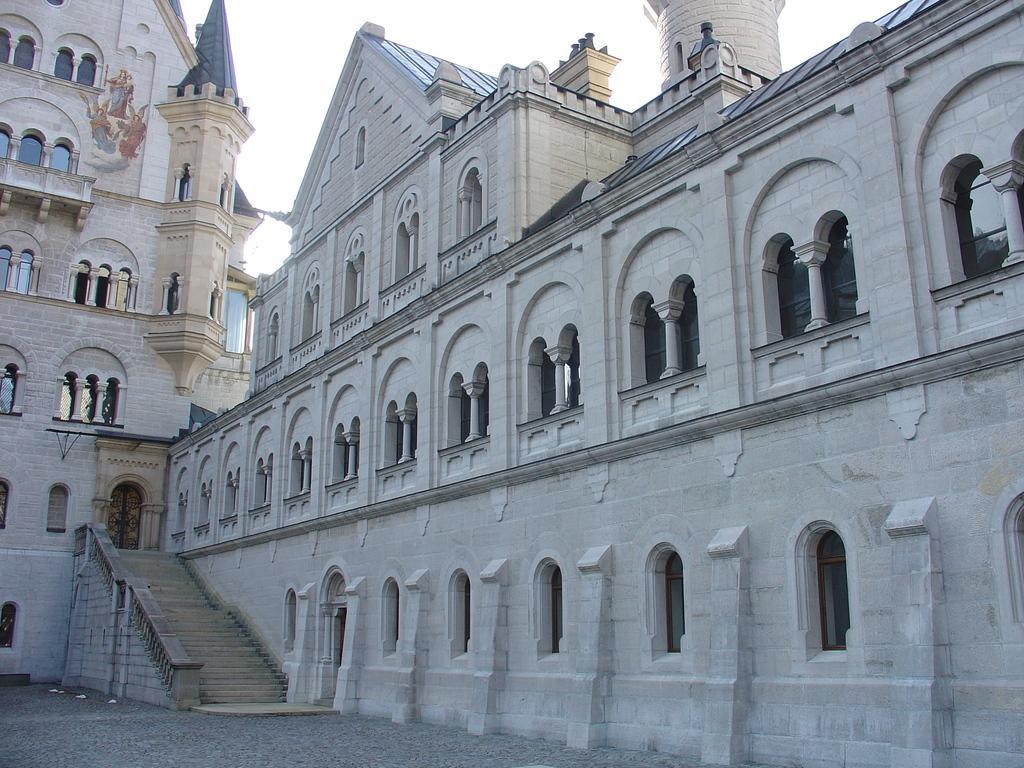Could you give a brief overview of what you see in this image? In the center of the image there is a building. 